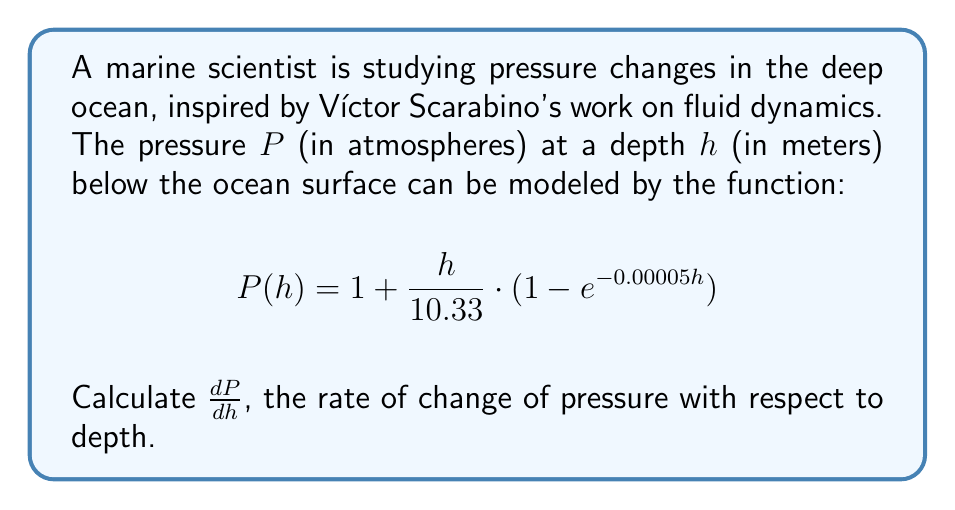Show me your answer to this math problem. To find $\frac{dP}{dh}$, we need to differentiate the given function $P(h)$ with respect to $h$. Let's break this down step-by-step:

1) First, let's rewrite the function in a more manageable form:
   $$P(h) = 1 + \frac{h}{10.33} - \frac{h}{10.33}e^{-0.00005h}$$

2) Now, we can differentiate each term separately:
   - The derivative of 1 is 0.
   - The derivative of $\frac{h}{10.33}$ is $\frac{1}{10.33}$.
   - For the third term, we need to use the product rule: $\frac{d}{dx}(uv) = u\frac{dv}{dx} + v\frac{du}{dx}$
     Let $u = \frac{h}{10.33}$ and $v = e^{-0.00005h}$
     $\frac{du}{dh} = \frac{1}{10.33}$
     $\frac{dv}{dh} = -0.00005e^{-0.00005h}$

3) Applying the product rule:
   $$\frac{d}{dh}(\frac{h}{10.33}e^{-0.00005h}) = \frac{1}{10.33}e^{-0.00005h} + \frac{h}{10.33}(-0.00005e^{-0.00005h})$$

4) Now, we can combine all parts:
   $$\frac{dP}{dh} = 0 + \frac{1}{10.33} - (\frac{1}{10.33}e^{-0.00005h} + \frac{h}{10.33}(-0.00005e^{-0.00005h}))$$

5) Simplifying:
   $$\frac{dP}{dh} = \frac{1}{10.33} - \frac{1}{10.33}e^{-0.00005h} + \frac{0.00005h}{10.33}e^{-0.00005h}$$

6) Finding a common denominator:
   $$\frac{dP}{dh} = \frac{1 - e^{-0.00005h} + 0.00005h \cdot e^{-0.00005h}}{10.33}$$

This final expression represents the rate of change of pressure with respect to depth in the ocean.
Answer: $$\frac{dP}{dh} = \frac{1 - e^{-0.00005h} + 0.00005h \cdot e^{-0.00005h}}{10.33}$$ 